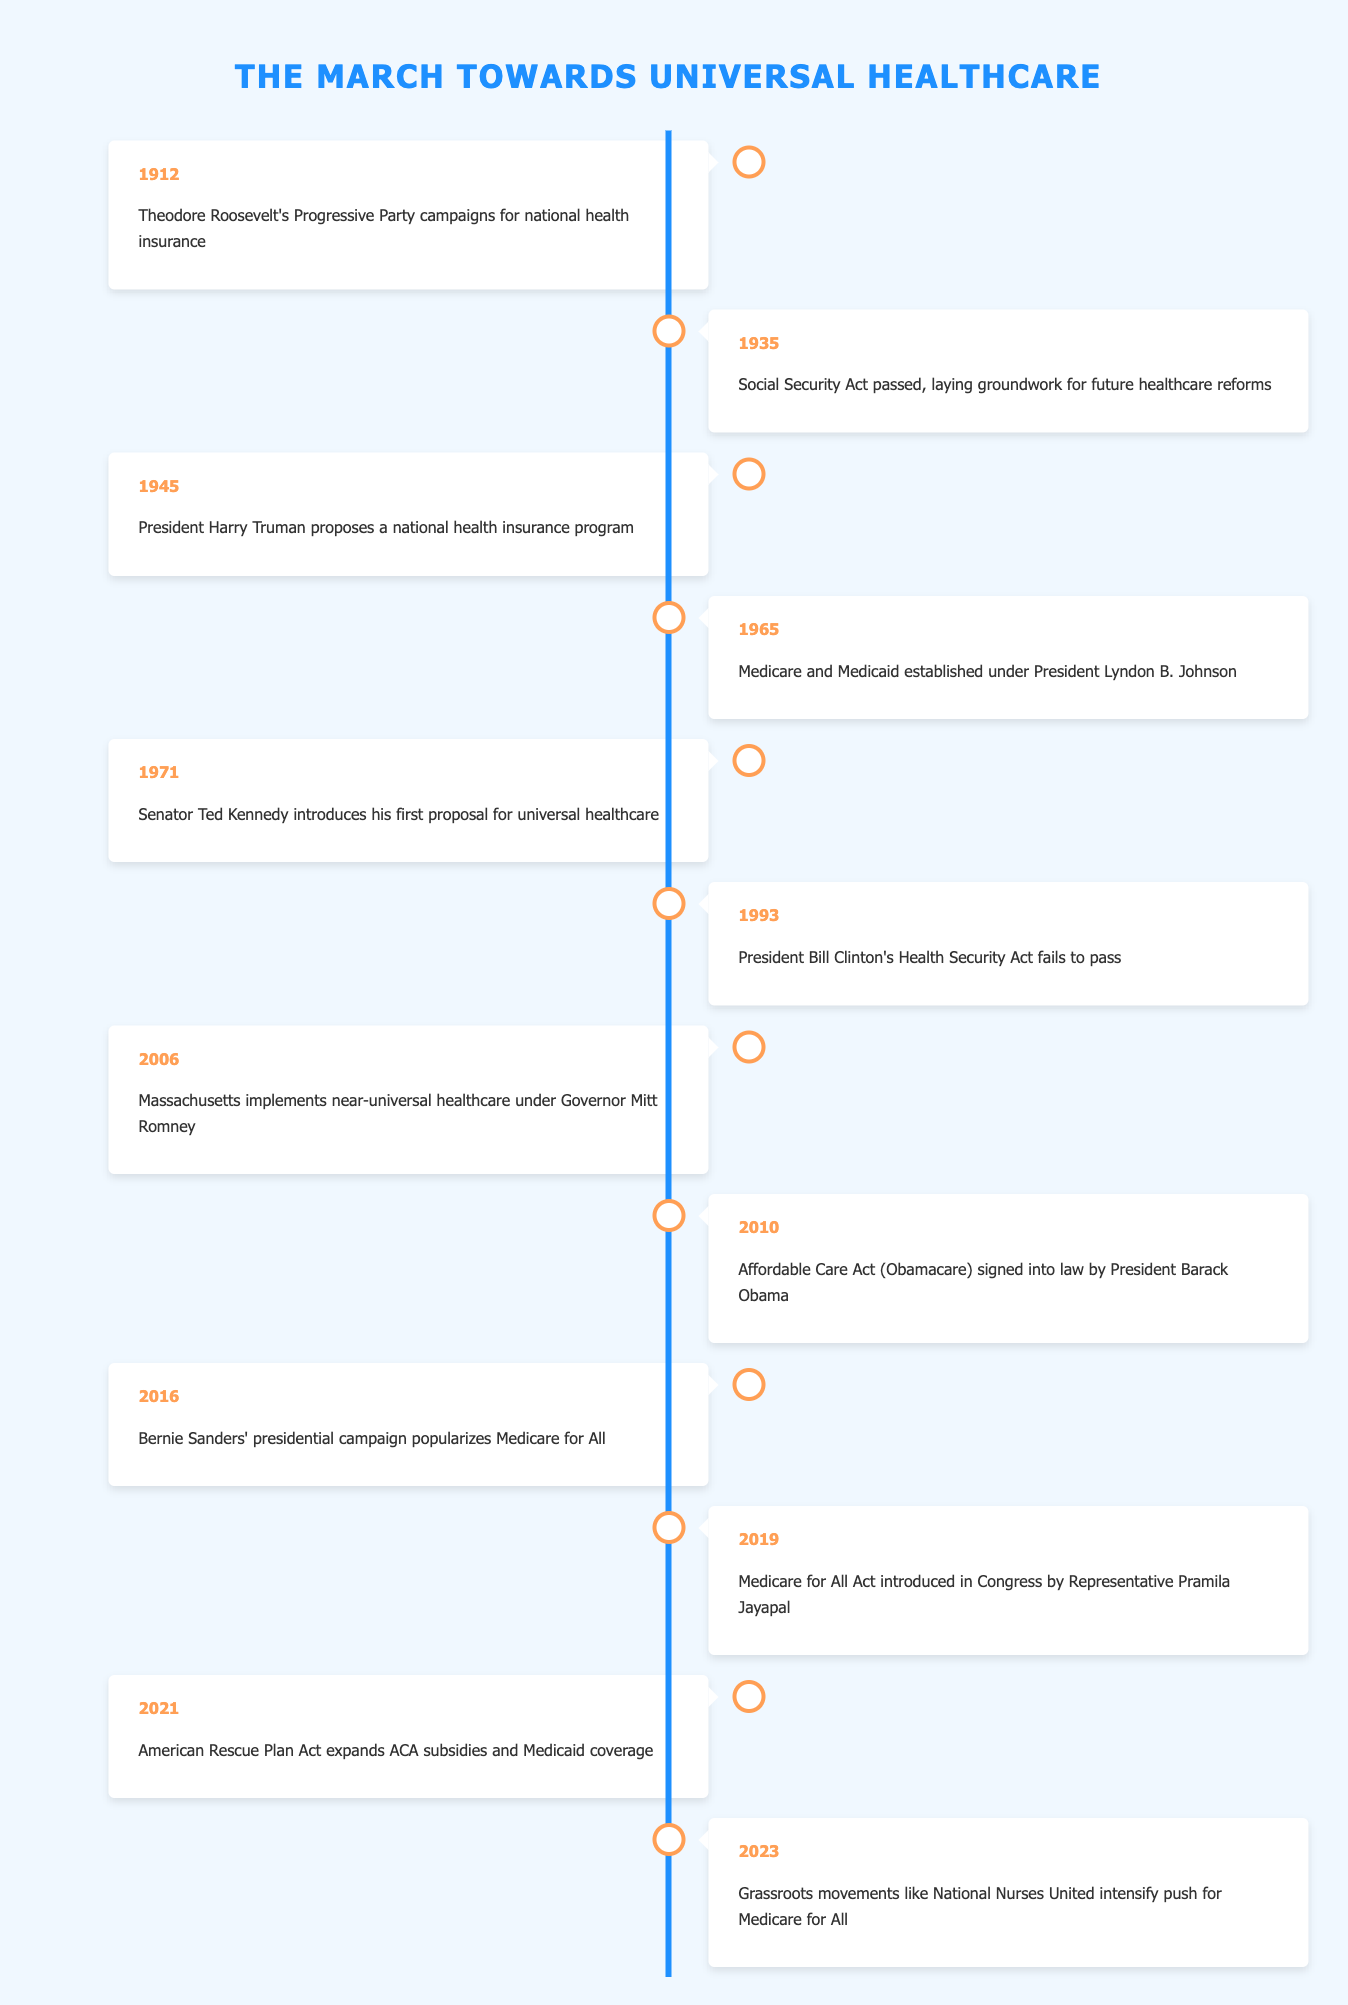What year did President Harry Truman propose a national health insurance program? The table lists the event in the year 1945, which clearly states that President Harry Truman proposed a national health insurance program that year.
Answer: 1945 What significant healthcare legislation was established in 1965? According to the table, in 1965, Medicare and Medicaid were established under President Lyndon B. Johnson.
Answer: Medicare and Medicaid Was the Health Security Act proposed by President Bill Clinton in 1993 successful? The table indicates that Bill Clinton's Health Security Act failed to pass in 1993, which confirms it was not successful.
Answer: No In what decade did Senator Ted Kennedy first introduce a proposal for universal healthcare? Looking at the timeline, Senator Ted Kennedy introduced his first proposal for universal healthcare in 1971, which falls in the 1970s decade.
Answer: 1970s How many years passed between the establishment of Medicare and Medicaid and the signing of the Affordable Care Act? The establishment of Medicare and Medicaid occurred in 1965, and the Affordable Care Act was signed in 2010. Thus, we calculate the difference: 2010 - 1965 = 45 years.
Answer: 45 years What grassroots movement intensified the push for Medicare for All in 2023? The table mentions that in 2023, grassroots movements like National Nurses United intensified the push for Medicare for All, indicating active advocacy during that year.
Answer: National Nurses United Is there a gap of more than 10 years between any two consecutive significant events in this timeline? Analyzing the timeline, the gap between 1993 (failed health security act) and 2006 (Massachusetts' near-universal healthcare) is 13 years, confirming there is a gap of over 10 years.
Answer: Yes Which event occurred shortly after the introduction of the Medicare for All Act in Congress? The Medicare for All Act was introduced in 2019, and the next significant event listed is the expansion of ACA subsidies and Medicaid coverage with the American Rescue Plan Act in 2021, so the event shortly after is in 2021.
Answer: American Rescue Plan Act in 2021 What was the last event listed on the timeline? The table shows that the last event listed is in 2023, highlighting the intensified push for Medicare for All by grassroots movements like National Nurses United.
Answer: Grassroots movements push for Medicare for All in 2023 